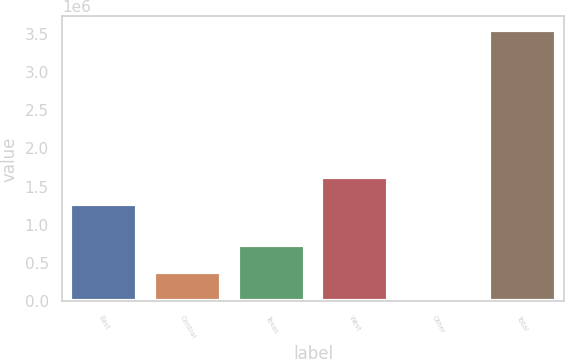Convert chart. <chart><loc_0><loc_0><loc_500><loc_500><bar_chart><fcel>East<fcel>Central<fcel>Texas<fcel>West<fcel>Other<fcel>Total<nl><fcel>1.27385e+06<fcel>381854<fcel>733911<fcel>1.6259e+06<fcel>29797<fcel>3.55037e+06<nl></chart> 